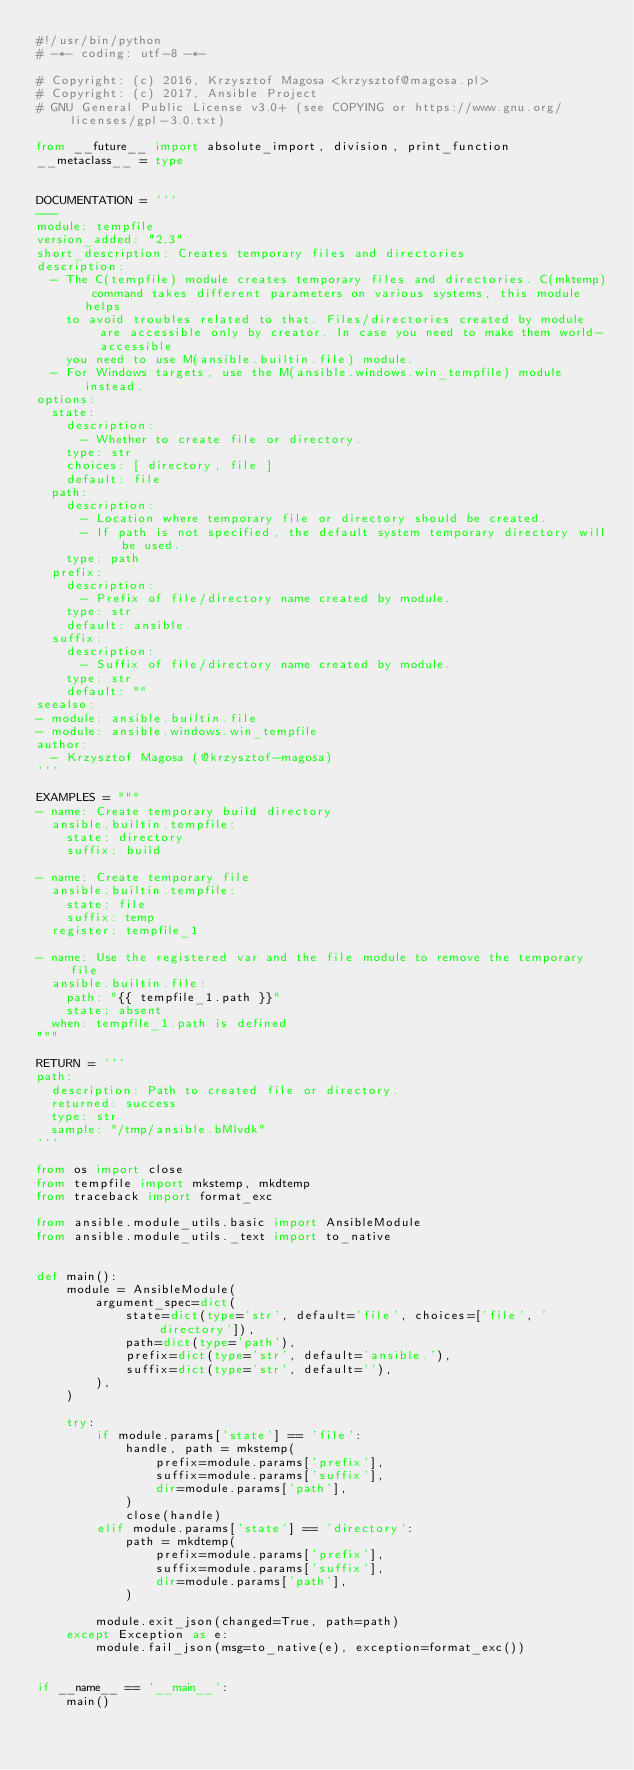<code> <loc_0><loc_0><loc_500><loc_500><_Python_>#!/usr/bin/python
# -*- coding: utf-8 -*-

# Copyright: (c) 2016, Krzysztof Magosa <krzysztof@magosa.pl>
# Copyright: (c) 2017, Ansible Project
# GNU General Public License v3.0+ (see COPYING or https://www.gnu.org/licenses/gpl-3.0.txt)

from __future__ import absolute_import, division, print_function
__metaclass__ = type


DOCUMENTATION = '''
---
module: tempfile
version_added: "2.3"
short_description: Creates temporary files and directories
description:
  - The C(tempfile) module creates temporary files and directories. C(mktemp) command takes different parameters on various systems, this module helps
    to avoid troubles related to that. Files/directories created by module are accessible only by creator. In case you need to make them world-accessible
    you need to use M(ansible.builtin.file) module.
  - For Windows targets, use the M(ansible.windows.win_tempfile) module instead.
options:
  state:
    description:
      - Whether to create file or directory.
    type: str
    choices: [ directory, file ]
    default: file
  path:
    description:
      - Location where temporary file or directory should be created.
      - If path is not specified, the default system temporary directory will be used.
    type: path
  prefix:
    description:
      - Prefix of file/directory name created by module.
    type: str
    default: ansible.
  suffix:
    description:
      - Suffix of file/directory name created by module.
    type: str
    default: ""
seealso:
- module: ansible.builtin.file
- module: ansible.windows.win_tempfile
author:
  - Krzysztof Magosa (@krzysztof-magosa)
'''

EXAMPLES = """
- name: Create temporary build directory
  ansible.builtin.tempfile:
    state: directory
    suffix: build

- name: Create temporary file
  ansible.builtin.tempfile:
    state: file
    suffix: temp
  register: tempfile_1

- name: Use the registered var and the file module to remove the temporary file
  ansible.builtin.file:
    path: "{{ tempfile_1.path }}"
    state: absent
  when: tempfile_1.path is defined
"""

RETURN = '''
path:
  description: Path to created file or directory.
  returned: success
  type: str
  sample: "/tmp/ansible.bMlvdk"
'''

from os import close
from tempfile import mkstemp, mkdtemp
from traceback import format_exc

from ansible.module_utils.basic import AnsibleModule
from ansible.module_utils._text import to_native


def main():
    module = AnsibleModule(
        argument_spec=dict(
            state=dict(type='str', default='file', choices=['file', 'directory']),
            path=dict(type='path'),
            prefix=dict(type='str', default='ansible.'),
            suffix=dict(type='str', default=''),
        ),
    )

    try:
        if module.params['state'] == 'file':
            handle, path = mkstemp(
                prefix=module.params['prefix'],
                suffix=module.params['suffix'],
                dir=module.params['path'],
            )
            close(handle)
        elif module.params['state'] == 'directory':
            path = mkdtemp(
                prefix=module.params['prefix'],
                suffix=module.params['suffix'],
                dir=module.params['path'],
            )

        module.exit_json(changed=True, path=path)
    except Exception as e:
        module.fail_json(msg=to_native(e), exception=format_exc())


if __name__ == '__main__':
    main()
</code> 